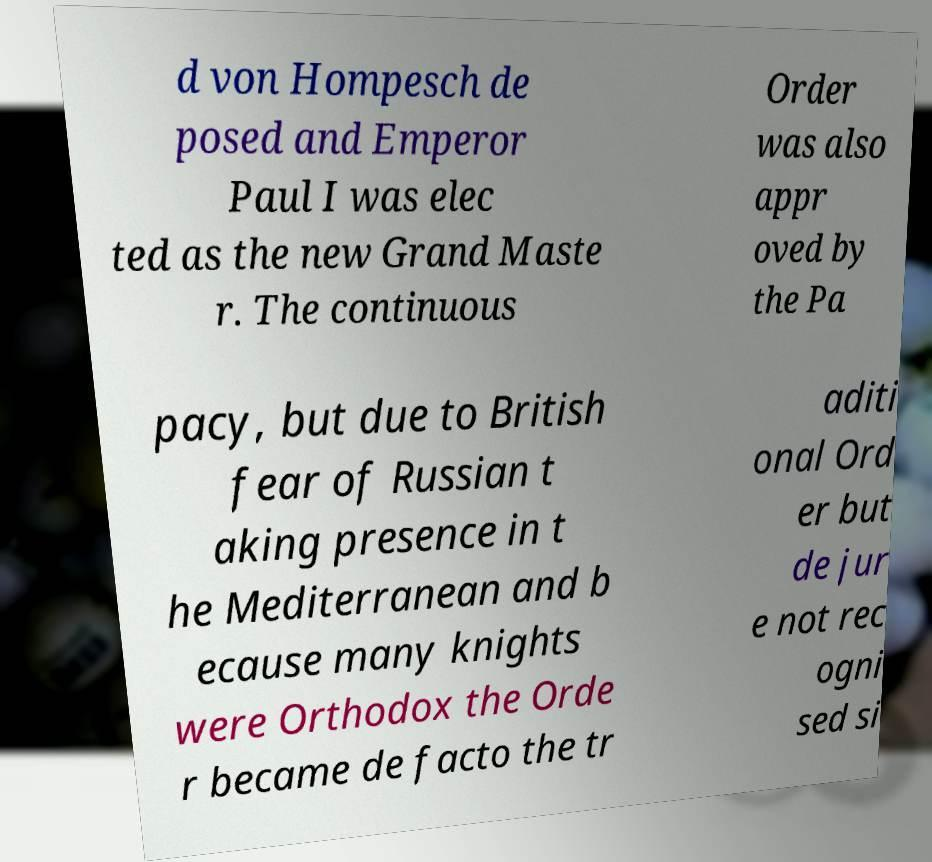Please read and relay the text visible in this image. What does it say? d von Hompesch de posed and Emperor Paul I was elec ted as the new Grand Maste r. The continuous Order was also appr oved by the Pa pacy, but due to British fear of Russian t aking presence in t he Mediterranean and b ecause many knights were Orthodox the Orde r became de facto the tr aditi onal Ord er but de jur e not rec ogni sed si 